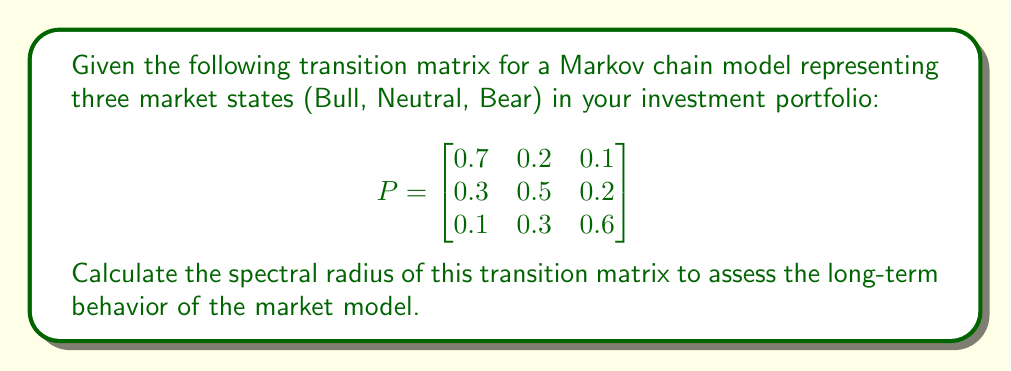Teach me how to tackle this problem. To calculate the spectral radius of the transition matrix, we need to follow these steps:

1) Find the characteristic equation of the matrix:
   $$\det(P - \lambda I) = 0$$

2) Expand the determinant:
   $$\begin{vmatrix}
   0.7-\lambda & 0.2 & 0.1 \\
   0.3 & 0.5-\lambda & 0.2 \\
   0.1 & 0.3 & 0.6-\lambda
   \end{vmatrix} = 0$$

3) Solve the resulting cubic equation:
   $$(0.7-\lambda)(0.5-\lambda)(0.6-\lambda) - 0.2 \cdot 0.3 \cdot 0.1 - 0.1 \cdot 0.2 \cdot 0.3 - 0.3 \cdot 0.2 \cdot (0.6-\lambda) - 0.1 \cdot (0.5-\lambda) \cdot 0.3 = 0$$

4) Simplify:
   $$-\lambda^3 + 1.8\lambda^2 - 0.98\lambda + 0.16 = 0$$

5) The roots of this equation are the eigenvalues. For a 3x3 matrix, finding these analytically is complex, so we would typically use numerical methods. However, for a transition matrix, we know that:
   - All eigenvalues have absolute value less than or equal to 1.
   - 1 is always an eigenvalue for a transition matrix.

6) Therefore, the spectral radius, which is the largest absolute value of the eigenvalues, is 1.

This result indicates that the Markov chain is regular and has a stable long-term behavior, converging to a unique stationary distribution regardless of the initial state.
Answer: 1 